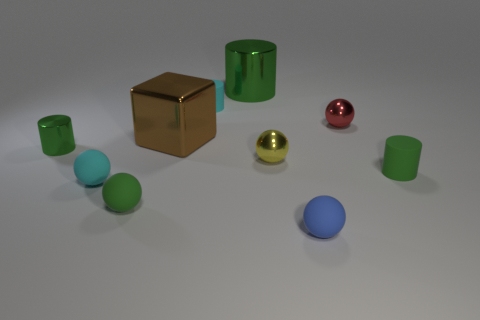Subtract all green cylinders. How many were subtracted if there are2green cylinders left? 1 Subtract all small blue spheres. How many spheres are left? 4 Subtract all cyan cylinders. How many cylinders are left? 3 Add 4 large yellow rubber cylinders. How many large yellow rubber cylinders exist? 4 Subtract 0 purple blocks. How many objects are left? 10 Subtract all cubes. How many objects are left? 9 Subtract 1 cylinders. How many cylinders are left? 3 Subtract all brown cylinders. Subtract all red blocks. How many cylinders are left? 4 Subtract all brown cylinders. How many cyan balls are left? 1 Subtract all big gray balls. Subtract all tiny green metal objects. How many objects are left? 9 